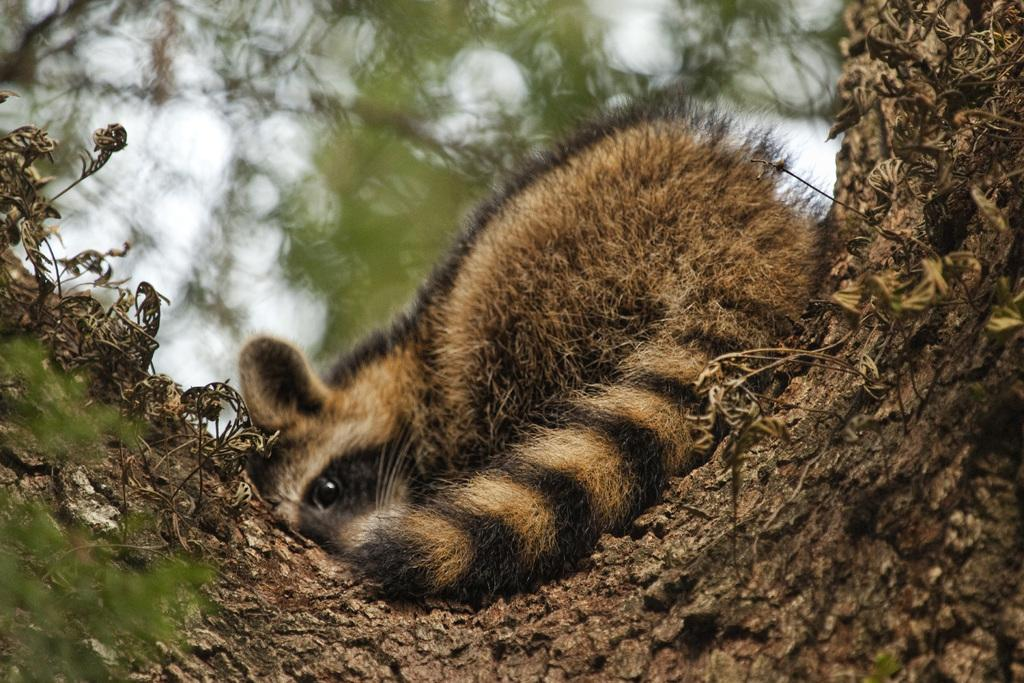What animal can be seen in the image? There is a squirrel in the image. Where is the squirrel located? The squirrel is on a tree. What can be seen in the background of the image? The sky and leaves are visible in the background of the image. How many flowers are present in the image? There are no flowers mentioned or visible in the image. 